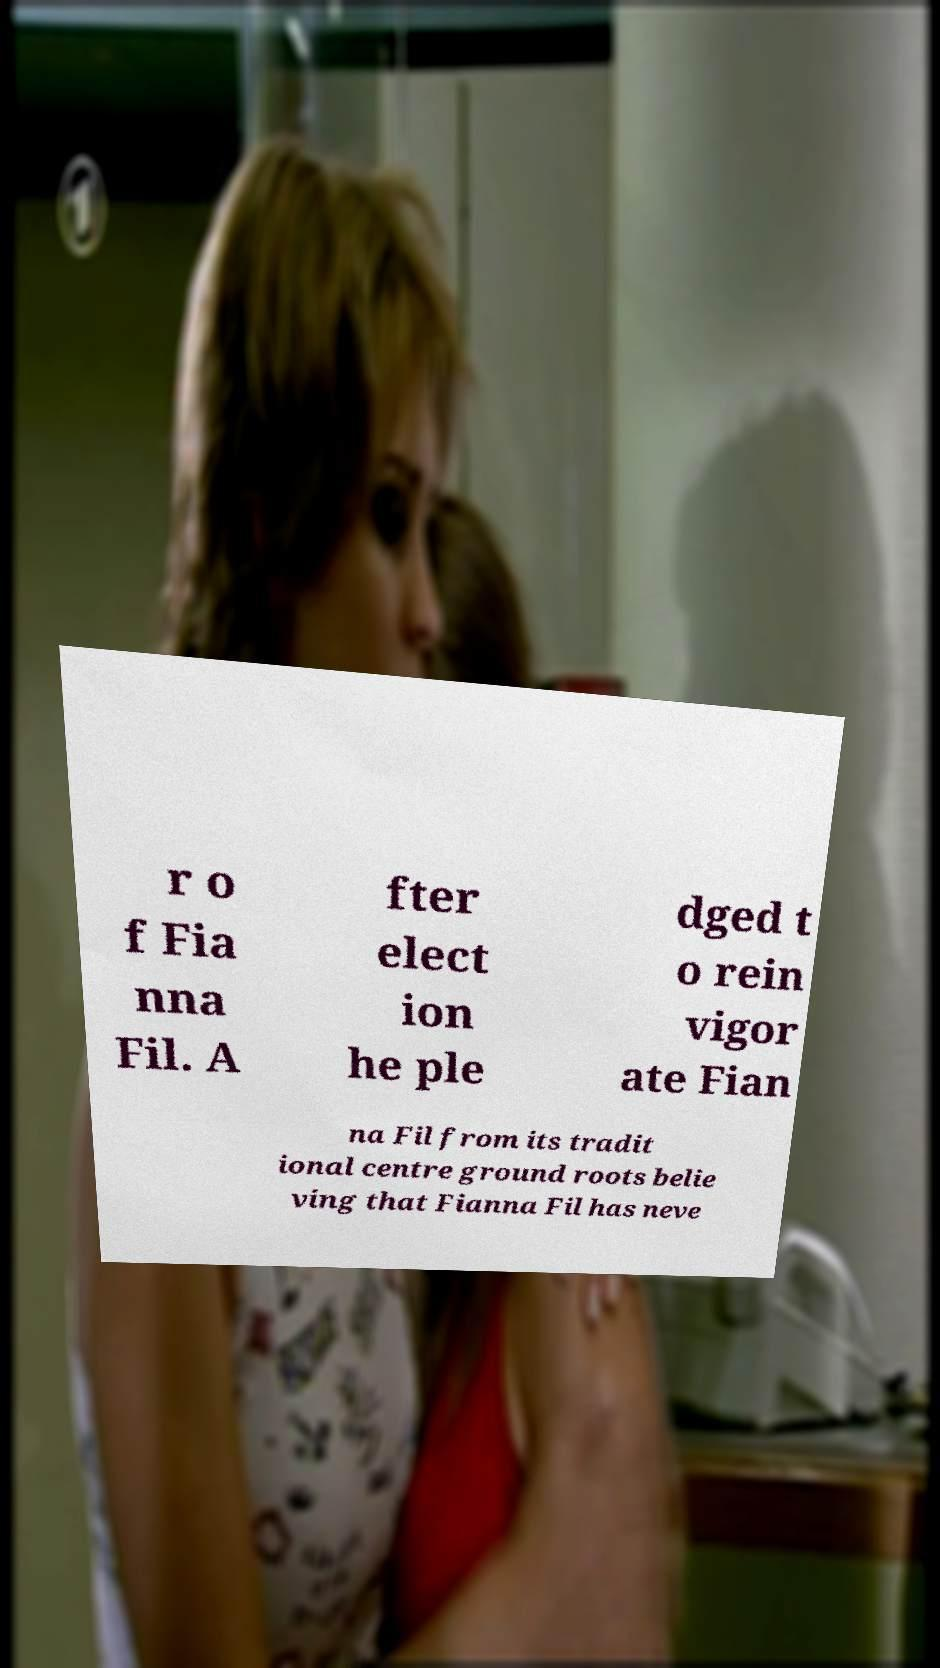Please read and relay the text visible in this image. What does it say? r o f Fia nna Fil. A fter elect ion he ple dged t o rein vigor ate Fian na Fil from its tradit ional centre ground roots belie ving that Fianna Fil has neve 